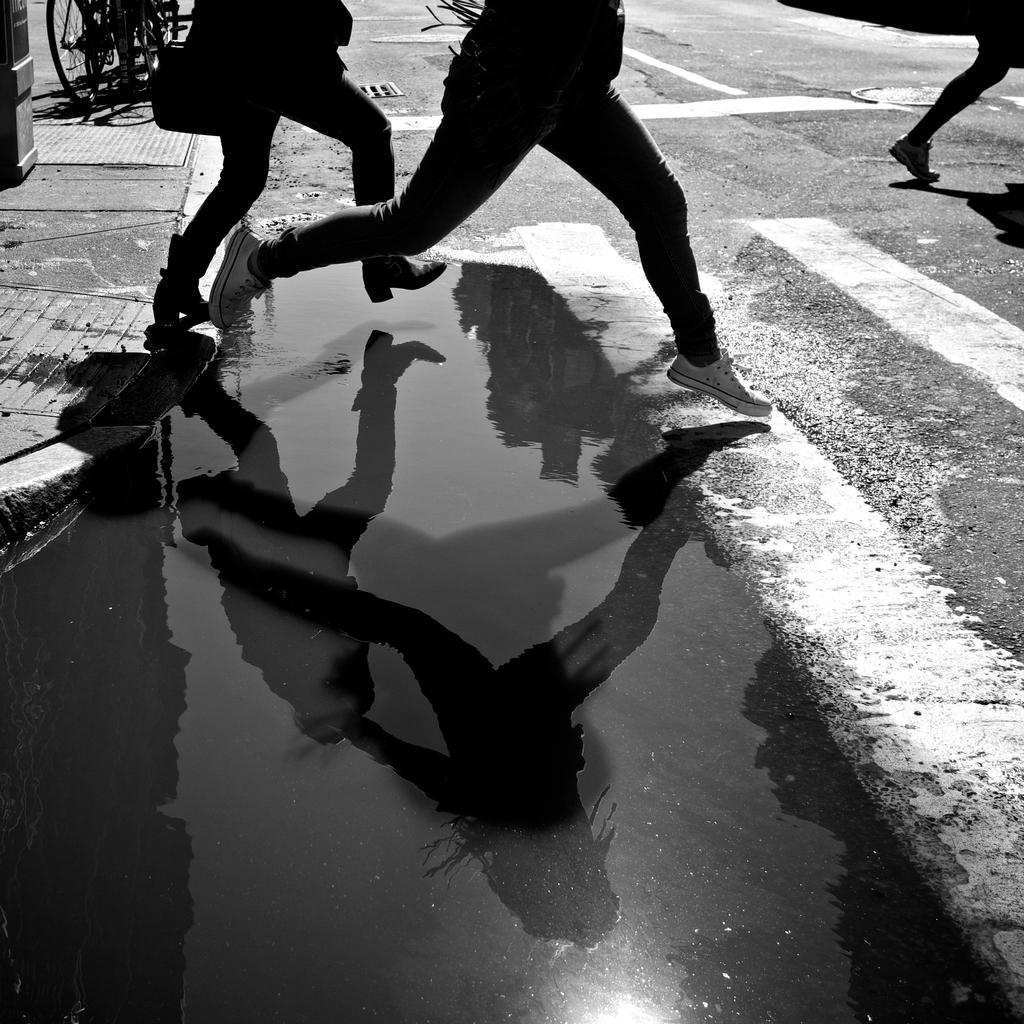What can be seen in the foreground of the image? There is water in the foreground of the image. Can you describe the people visible in the image? There are people visible in the image. What type of transportation is present on a walkway in the image? Bicycles are present on a walkway in the image. What type of pathway is visible in the image? There is a road in the image. What type of science experiment is being conducted in the image? There is no indication of a science experiment being conducted in the image. Can you describe the swing that is present in the image? There is no swing present in the image. 